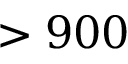<formula> <loc_0><loc_0><loc_500><loc_500>> 9 0 0</formula> 